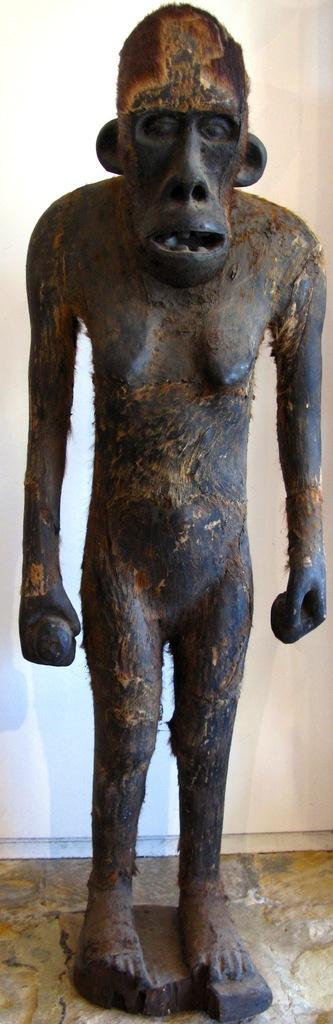What is the main subject of the image? There is a black monkey sculpture in the image. Can you describe the position of the sculpture? The sculpture is standing. What type of advice does the pot give in the image? There is no pot present in the image, and therefore no advice can be given. 